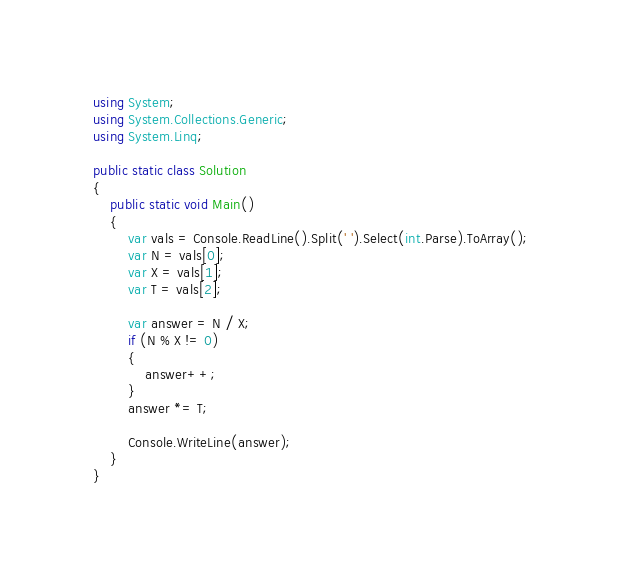Convert code to text. <code><loc_0><loc_0><loc_500><loc_500><_C#_>using System;
using System.Collections.Generic;
using System.Linq;

public static class Solution
{
    public static void Main()
    {
        var vals = Console.ReadLine().Split(' ').Select(int.Parse).ToArray();
        var N = vals[0];
        var X = vals[1];
        var T = vals[2];

        var answer = N / X;
        if (N % X != 0)
        {
            answer++;
        }
        answer *= T;

        Console.WriteLine(answer);
    }
}</code> 